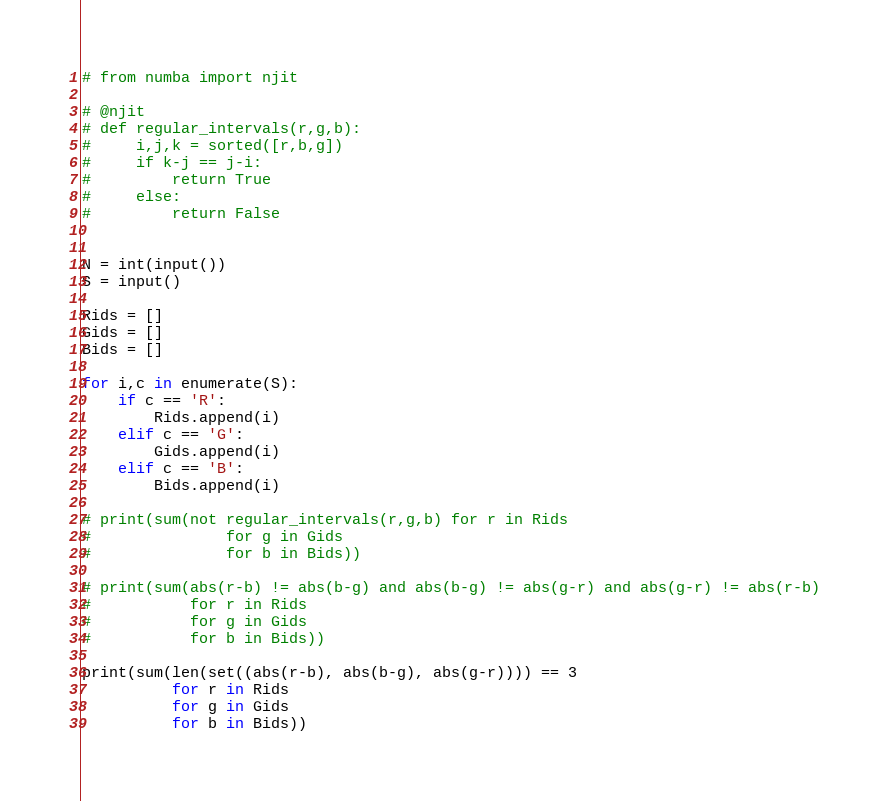<code> <loc_0><loc_0><loc_500><loc_500><_Python_># from numba import njit

# @njit
# def regular_intervals(r,g,b):
#     i,j,k = sorted([r,b,g])
#     if k-j == j-i:
#         return True
#     else:
#         return False


N = int(input())
S = input()

Rids = []
Gids = []
Bids = []

for i,c in enumerate(S):
    if c == 'R':
        Rids.append(i)
    elif c == 'G':
        Gids.append(i)
    elif c == 'B':
        Bids.append(i)

# print(sum(not regular_intervals(r,g,b) for r in Rids
#               for g in Gids
#               for b in Bids))

# print(sum(abs(r-b) != abs(b-g) and abs(b-g) != abs(g-r) and abs(g-r) != abs(r-b)
#           for r in Rids
#           for g in Gids
#           for b in Bids))

print(sum(len(set((abs(r-b), abs(b-g), abs(g-r)))) == 3
          for r in Rids
          for g in Gids
          for b in Bids))

</code> 